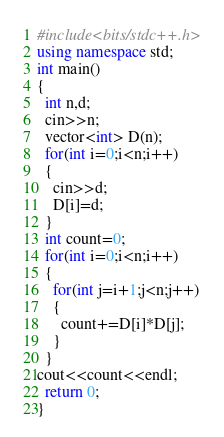<code> <loc_0><loc_0><loc_500><loc_500><_C++_>#include<bits/stdc++.h>
using namespace std;
int main()
{
  int n,d;
  cin>>n;
  vector<int> D(n);
  for(int i=0;i<n;i++)
  {
    cin>>d;
    D[i]=d;
  }
  int count=0;
  for(int i=0;i<n;i++)
  {
    for(int j=i+1;j<n;j++)
    {
      count+=D[i]*D[j];
    }
  }
cout<<count<<endl;
  return 0;
}
</code> 